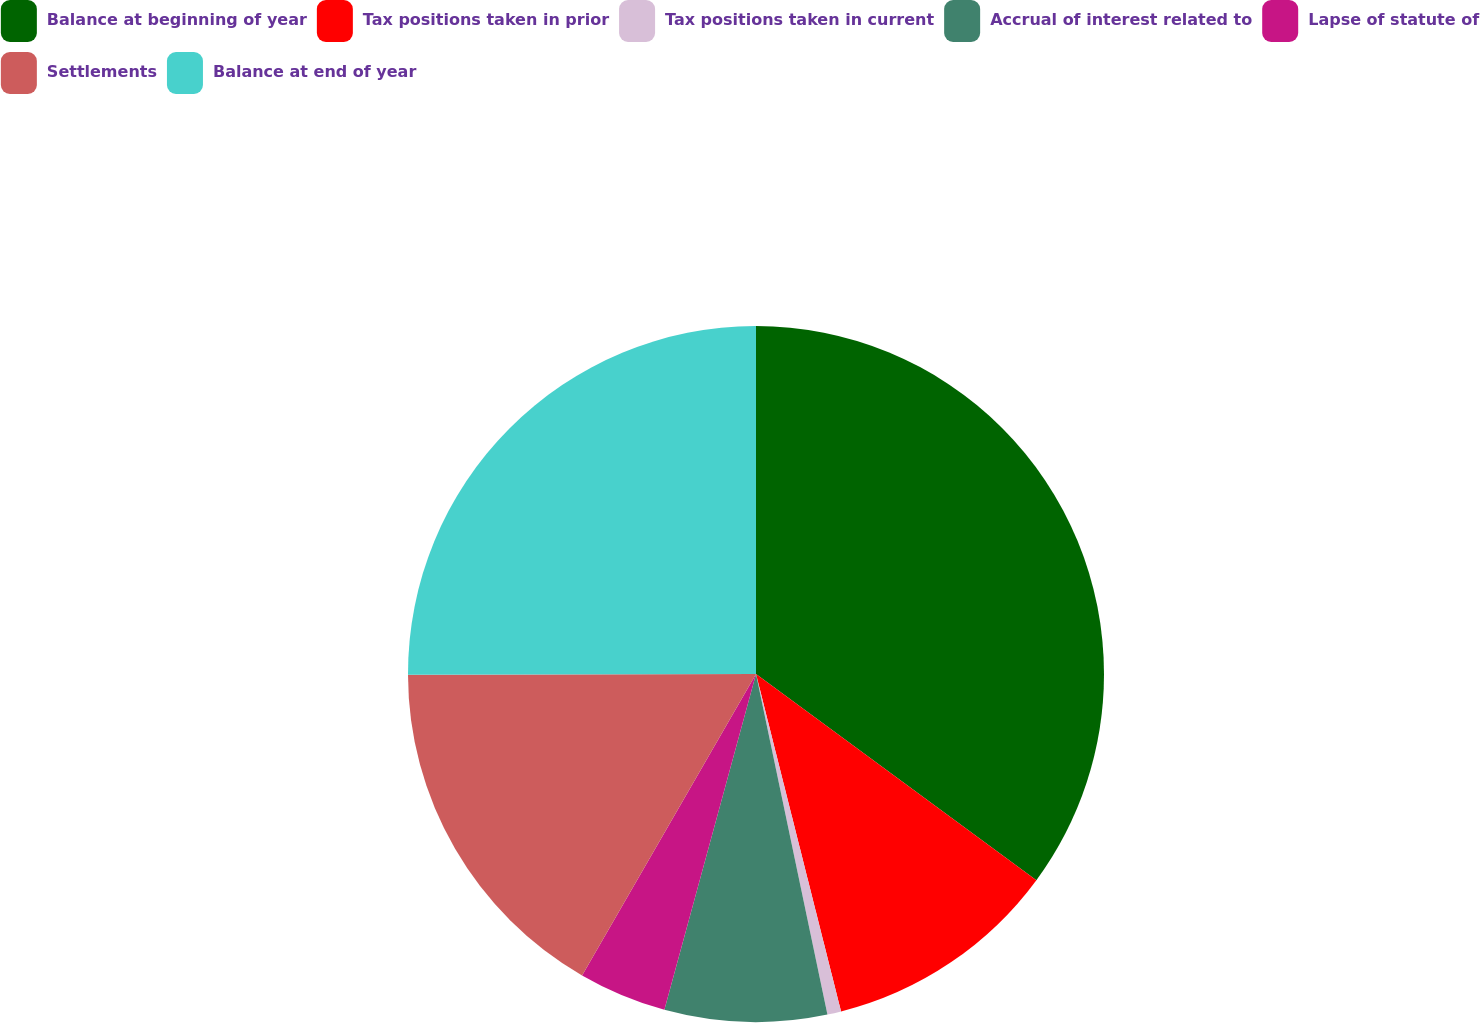Convert chart to OTSL. <chart><loc_0><loc_0><loc_500><loc_500><pie_chart><fcel>Balance at beginning of year<fcel>Tax positions taken in prior<fcel>Tax positions taken in current<fcel>Accrual of interest related to<fcel>Lapse of statute of<fcel>Settlements<fcel>Balance at end of year<nl><fcel>35.09%<fcel>10.98%<fcel>0.64%<fcel>7.53%<fcel>4.09%<fcel>16.64%<fcel>25.03%<nl></chart> 